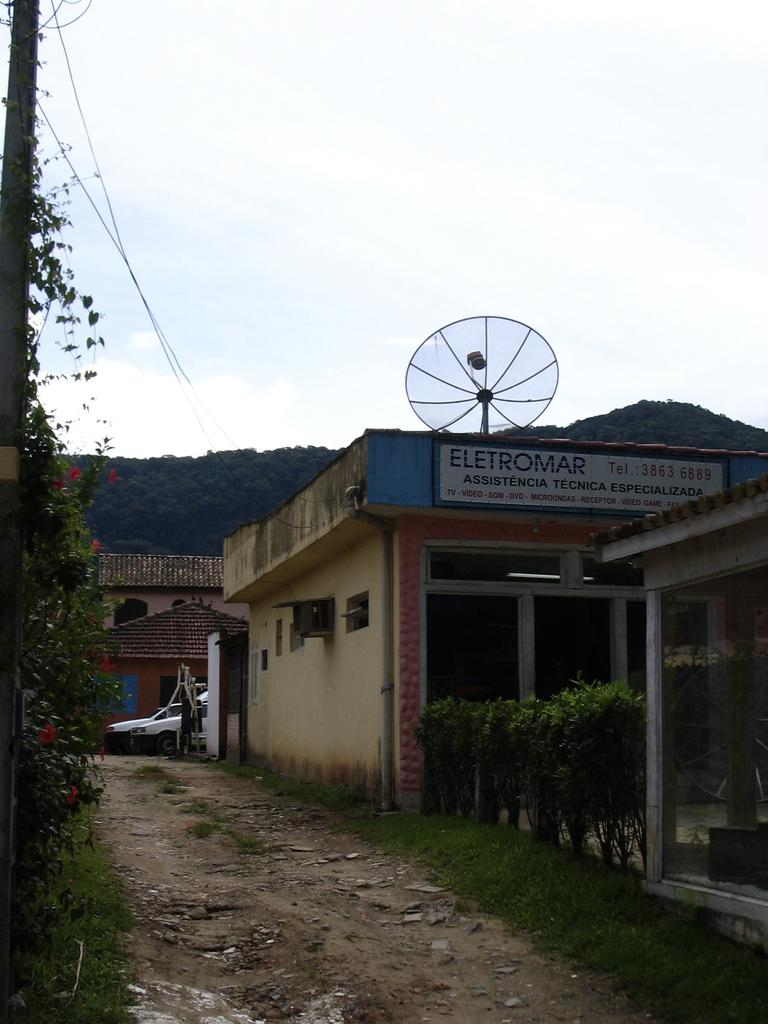What type of surface can be seen in the image? There is a pathway in the image. What type of vegetation is present in the image? Grass, plants, and trees are visible in the image. What type of structures are in the image? There are houses in the image. What type of transportation is visible in the image? Vehicles are moving on the road in the image. What else can be seen in the image? Wires are visible in the image. What is visible in the background of the image? The sky is visible in the background of the image. How many pies are being sold at the gate in the image? There is no gate or pies present in the image. What type of things are being sold at the gate in the image? There is no gate or things being sold in the image. 